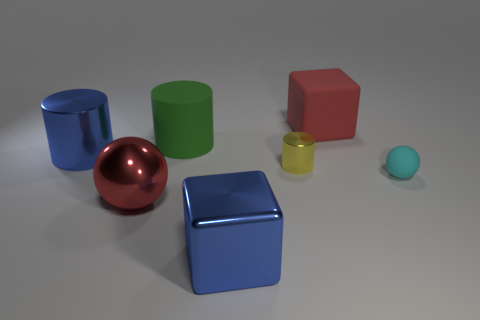Is the number of rubber cylinders that are behind the tiny rubber sphere greater than the number of small yellow things right of the large red rubber block?
Keep it short and to the point. Yes. There is a tiny shiny object; is it the same shape as the blue thing left of the big green object?
Your answer should be compact. Yes. Do the cylinder to the right of the matte cylinder and the rubber object in front of the big blue metallic cylinder have the same size?
Offer a terse response. Yes. Are there any big cylinders behind the large blue metallic object that is left of the red sphere that is left of the large green matte thing?
Offer a very short reply. Yes. Is the number of matte cylinders that are behind the big green matte cylinder less than the number of rubber objects behind the small yellow metallic cylinder?
Give a very brief answer. Yes. There is a green thing that is made of the same material as the cyan ball; what shape is it?
Keep it short and to the point. Cylinder. What size is the metallic cylinder that is to the right of the big shiny object in front of the big red thing on the left side of the red block?
Your answer should be compact. Small. Is the number of yellow metal things greater than the number of big yellow matte cylinders?
Your answer should be compact. Yes. There is a big cylinder on the left side of the large green rubber cylinder; does it have the same color as the cube that is in front of the big blue cylinder?
Provide a short and direct response. Yes. Do the large object to the right of the yellow cylinder and the big block that is in front of the small cyan rubber thing have the same material?
Your answer should be compact. No. 